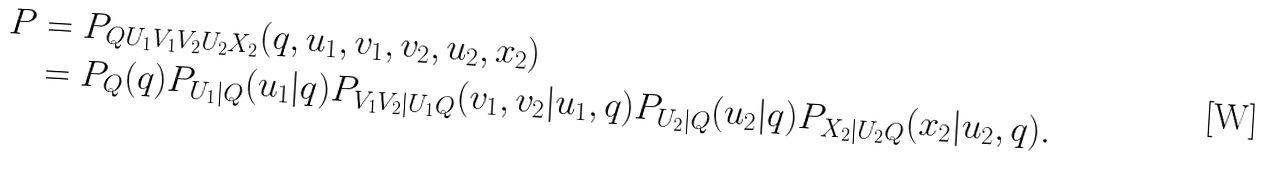Convert formula to latex. <formula><loc_0><loc_0><loc_500><loc_500>P & = P _ { Q U _ { 1 } V _ { 1 } V _ { 2 } U _ { 2 } X _ { 2 } } ( q , u _ { 1 } , v _ { 1 } , v _ { 2 } , u _ { 2 } , x _ { 2 } ) \\ & = P _ { Q } ( q ) P _ { U _ { 1 } | Q } ( u _ { 1 } | q ) P _ { V _ { 1 } V _ { 2 } | U _ { 1 } Q } ( v _ { 1 } , v _ { 2 } | u _ { 1 } , q ) P _ { U _ { 2 } | Q } ( u _ { 2 } | q ) P _ { X _ { 2 } | U _ { 2 } Q } ( x _ { 2 } | u _ { 2 } , q ) .</formula> 